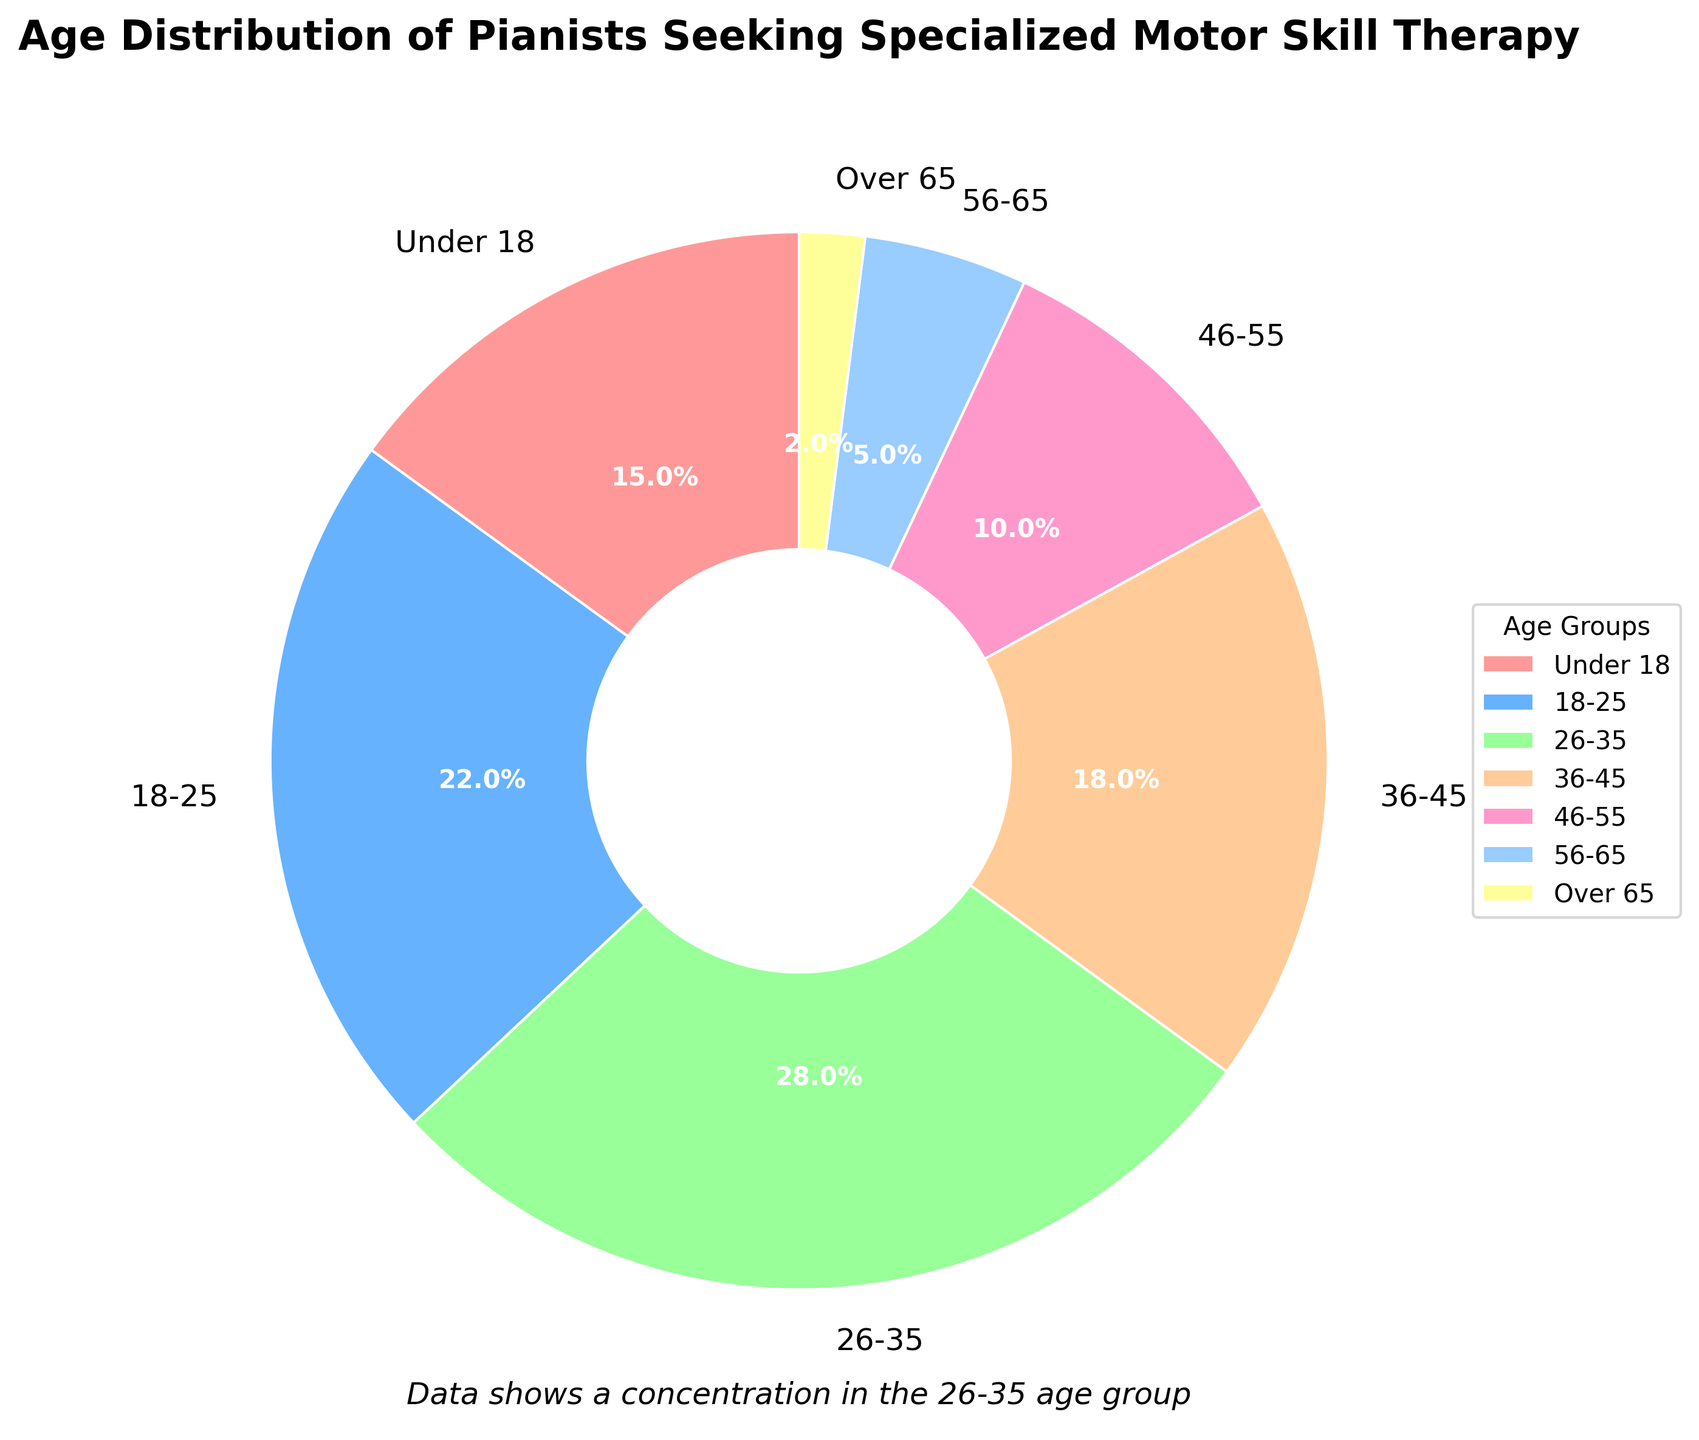What is the largest age group of pianists seeking therapy? Check the segment of the pie chart that occupies the largest area and has the highest percentage label. The 26-35 age group has the largest segment with 28%.
Answer: 26-35 Which age group has the least number of pianists seeking therapy? Look for the smallest segment in the pie chart. The "Over 65" age group has the smallest segment with 2%.
Answer: Over 65 What combined percentage of pianists seeking therapy are aged 36-45 and 46-55? Sum the percentages of the 36-45 and 46-55 age groups from the chart: 18% + 10% = 28%.
Answer: 28% How does the percentage of pianists aged 18-25 compare to those aged under 18? Compare the two segments' percentages. The 18-25 age group has 22%, and the 'Under 18' group has 15%. 22% is greater than 15%.
Answer: 18-25 is greater Which age group's segment is depicted with a red color? Identify the segment of the pie chart colored in red. The "Under 18" age group segment is red.
Answer: Under 18 How many age groups have a percentage greater than 15%? Count the segments with percentages higher than 15%. The age groups "Under 18", "18-25", "26-35", and "36-45" meet this criterion. There are 4 age groups.
Answer: 4 What is the percentage range (difference between the largest and smallest percentages) shown in the pie chart? Subtract the smallest percentage (2% for Over 65) from the largest percentage (28% for 26-35). The range is 28% - 2% = 26%.
Answer: 26% Which age group’s segment is represented in yellow? Find the segment of the pie chart that is colored yellow. The "56-65" age group segment is yellow.
Answer: 56-65 What combined percentage do the age groups under 18 and over 65 represent? Sum the percentages of the "Under 18" and "Over 65" age groups: 15% + 2% = 17%.
Answer: 17% Which two age groups together constitute exactly half of the therapy-seeking pianists? Add 28% (26-35 age group) and 22% (18-25 age group) to check if their sum is 50%. 28% + 22% = 50%.
Answer: 18-25 and 26-35 